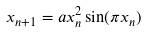Convert formula to latex. <formula><loc_0><loc_0><loc_500><loc_500>x _ { n + 1 } = a x _ { n } ^ { 2 } \sin ( \pi x _ { n } )</formula> 